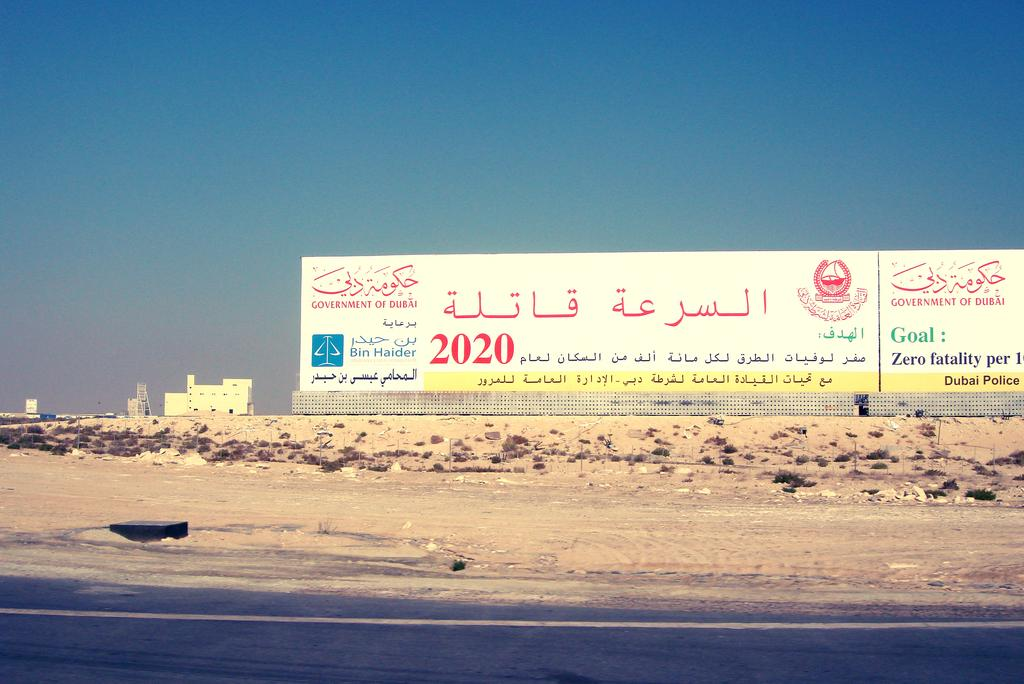<image>
Create a compact narrative representing the image presented. The Government of Dubai has erected a very large billboard calling for a fatality rate of zero. 